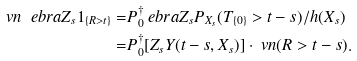Convert formula to latex. <formula><loc_0><loc_0><loc_500><loc_500>\ v n \ e b r a { Z _ { s } 1 _ { \{ R > t \} } } = & P ^ { \dagger } _ { 0 } \ e b r a { Z _ { s } P _ { X _ { s } } ( T _ { \{ 0 \} } > t - s ) / h ( X _ { s } ) } \\ = & P ^ { \dagger } _ { 0 } [ Z _ { s } Y ( t - s , X _ { s } ) ] \cdot \ v n ( R > t - s ) .</formula> 